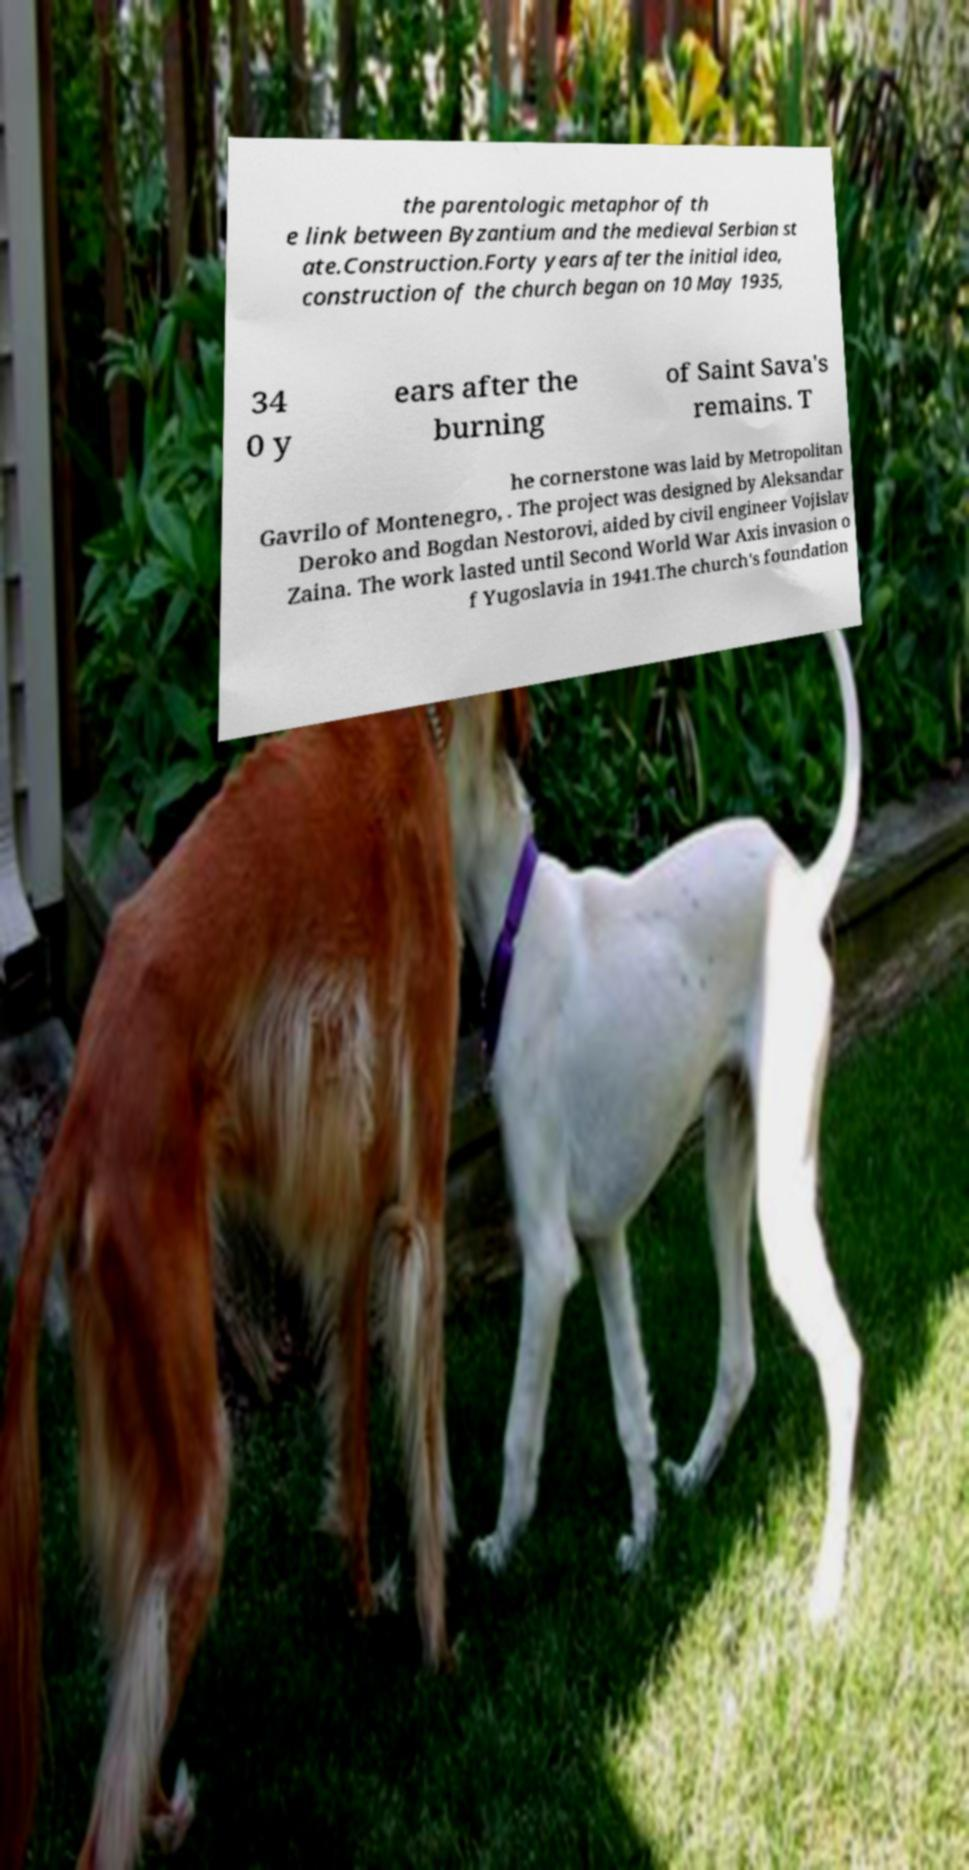Please identify and transcribe the text found in this image. the parentologic metaphor of th e link between Byzantium and the medieval Serbian st ate.Construction.Forty years after the initial idea, construction of the church began on 10 May 1935, 34 0 y ears after the burning of Saint Sava's remains. T he cornerstone was laid by Metropolitan Gavrilo of Montenegro, . The project was designed by Aleksandar Deroko and Bogdan Nestorovi, aided by civil engineer Vojislav Zaina. The work lasted until Second World War Axis invasion o f Yugoslavia in 1941.The church's foundation 